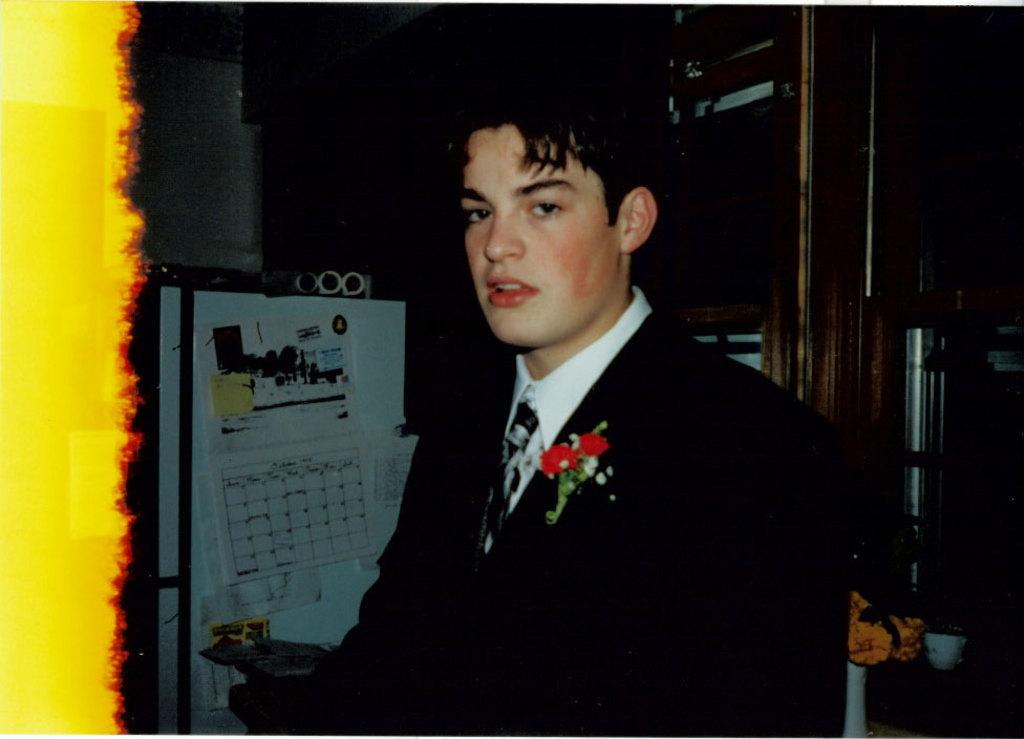Who or what is the main subject in the center of the image? There is a person in the center of the image. What can be seen in the background of the image? There is a door and a fridge in the background of the image. What is on the fridge? There are papers on the fridge. What other objects are visible in the image? There are other objects visible in the image, but their specific details are not mentioned in the provided facts. What type of pleasure can be seen enjoying the company of the person in the image? There is no indication of pleasure or company in the image, as it only features a person, a door, a fridge, and papers on the fridge. What kind of bun is being prepared in the image? There is no bun or any indication of food preparation in the image. 